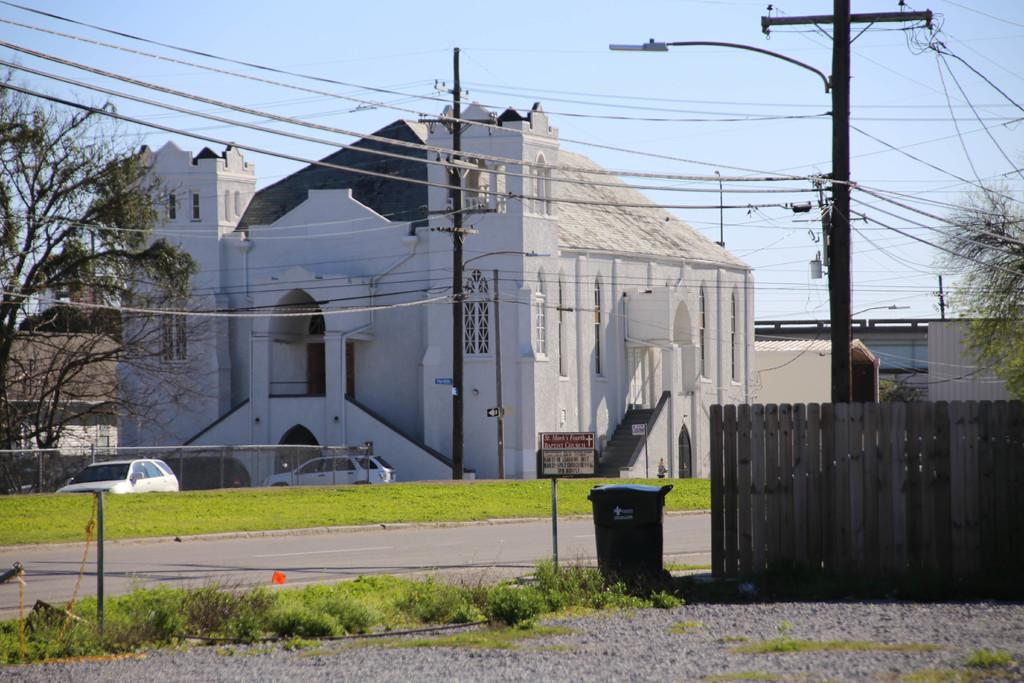What object is present in the image for waste disposal? There is a dustbin in the image. What type of vegetation can be seen in the image? There is grass, plants, and trees in the image. What structures are visible in the image? There are vehicles, buildings, poles, and a fence in the image. What additional objects can be seen in the image? There are lights and boards in the image. What part of the natural environment is visible in the background of the image? The sky is visible in the background of the image. How many eggs are visible on the fence in the image? There are no eggs present in the image; it features a dustbin, grass, plants, vehicles, buildings, poles, lights, boards, and trees. What type of finger can be seen interacting with the dustbin in the image? There are no fingers visible in the image; it is a still image with no human interaction. 